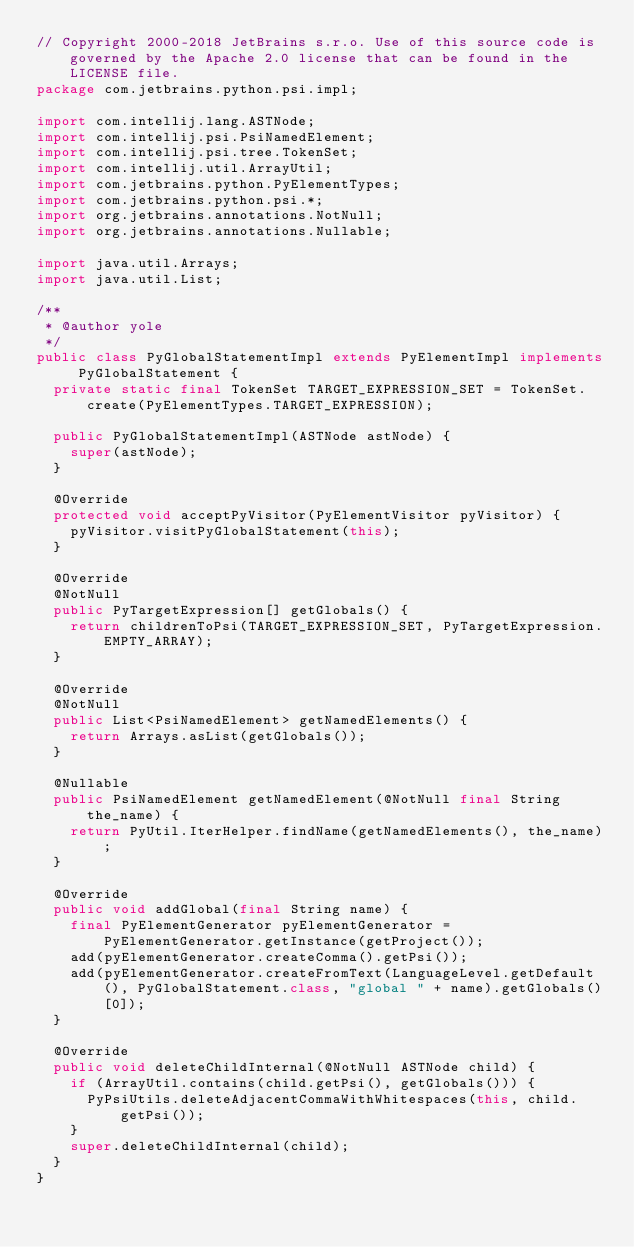Convert code to text. <code><loc_0><loc_0><loc_500><loc_500><_Java_>// Copyright 2000-2018 JetBrains s.r.o. Use of this source code is governed by the Apache 2.0 license that can be found in the LICENSE file.
package com.jetbrains.python.psi.impl;

import com.intellij.lang.ASTNode;
import com.intellij.psi.PsiNamedElement;
import com.intellij.psi.tree.TokenSet;
import com.intellij.util.ArrayUtil;
import com.jetbrains.python.PyElementTypes;
import com.jetbrains.python.psi.*;
import org.jetbrains.annotations.NotNull;
import org.jetbrains.annotations.Nullable;

import java.util.Arrays;
import java.util.List;

/**
 * @author yole
 */
public class PyGlobalStatementImpl extends PyElementImpl implements PyGlobalStatement {
  private static final TokenSet TARGET_EXPRESSION_SET = TokenSet.create(PyElementTypes.TARGET_EXPRESSION);

  public PyGlobalStatementImpl(ASTNode astNode) {
    super(astNode);
  }

  @Override
  protected void acceptPyVisitor(PyElementVisitor pyVisitor) {
    pyVisitor.visitPyGlobalStatement(this);
  }

  @Override
  @NotNull
  public PyTargetExpression[] getGlobals() {
    return childrenToPsi(TARGET_EXPRESSION_SET, PyTargetExpression.EMPTY_ARRAY);
  }

  @Override
  @NotNull
  public List<PsiNamedElement> getNamedElements() {
    return Arrays.asList(getGlobals());
  }

  @Nullable
  public PsiNamedElement getNamedElement(@NotNull final String the_name) {
    return PyUtil.IterHelper.findName(getNamedElements(), the_name);
  }

  @Override
  public void addGlobal(final String name) {
    final PyElementGenerator pyElementGenerator = PyElementGenerator.getInstance(getProject());
    add(pyElementGenerator.createComma().getPsi());
    add(pyElementGenerator.createFromText(LanguageLevel.getDefault(), PyGlobalStatement.class, "global " + name).getGlobals()[0]);
  }

  @Override
  public void deleteChildInternal(@NotNull ASTNode child) {
    if (ArrayUtil.contains(child.getPsi(), getGlobals())) {
      PyPsiUtils.deleteAdjacentCommaWithWhitespaces(this, child.getPsi());
    }
    super.deleteChildInternal(child);
  }
}
</code> 